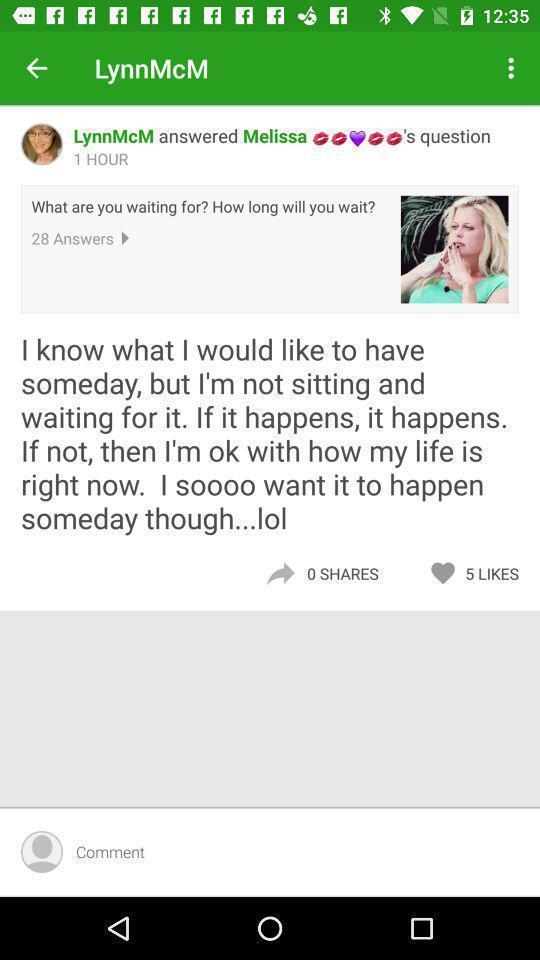Summarize the information in this screenshot. Page showing information about a profile. 